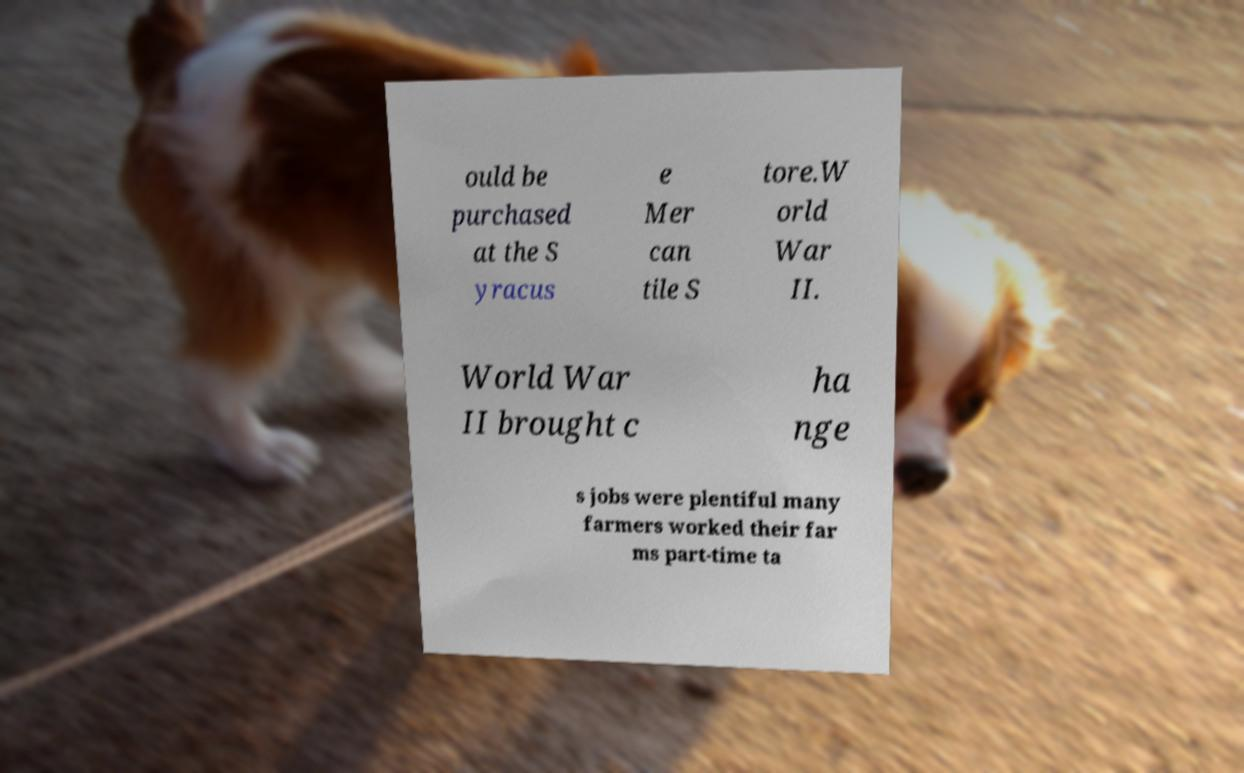For documentation purposes, I need the text within this image transcribed. Could you provide that? ould be purchased at the S yracus e Mer can tile S tore.W orld War II. World War II brought c ha nge s jobs were plentiful many farmers worked their far ms part-time ta 